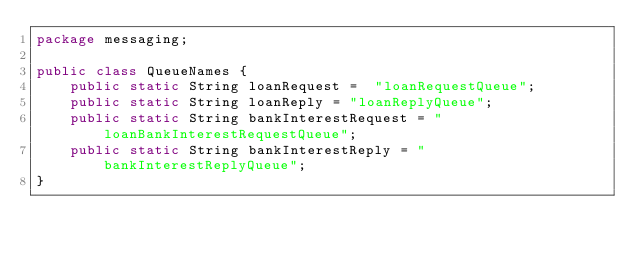<code> <loc_0><loc_0><loc_500><loc_500><_Java_>package messaging;

public class QueueNames {
    public static String loanRequest =  "loanRequestQueue";
    public static String loanReply = "loanReplyQueue";
    public static String bankInterestRequest = "loanBankInterestRequestQueue";
    public static String bankInterestReply = "bankInterestReplyQueue";
}
</code> 